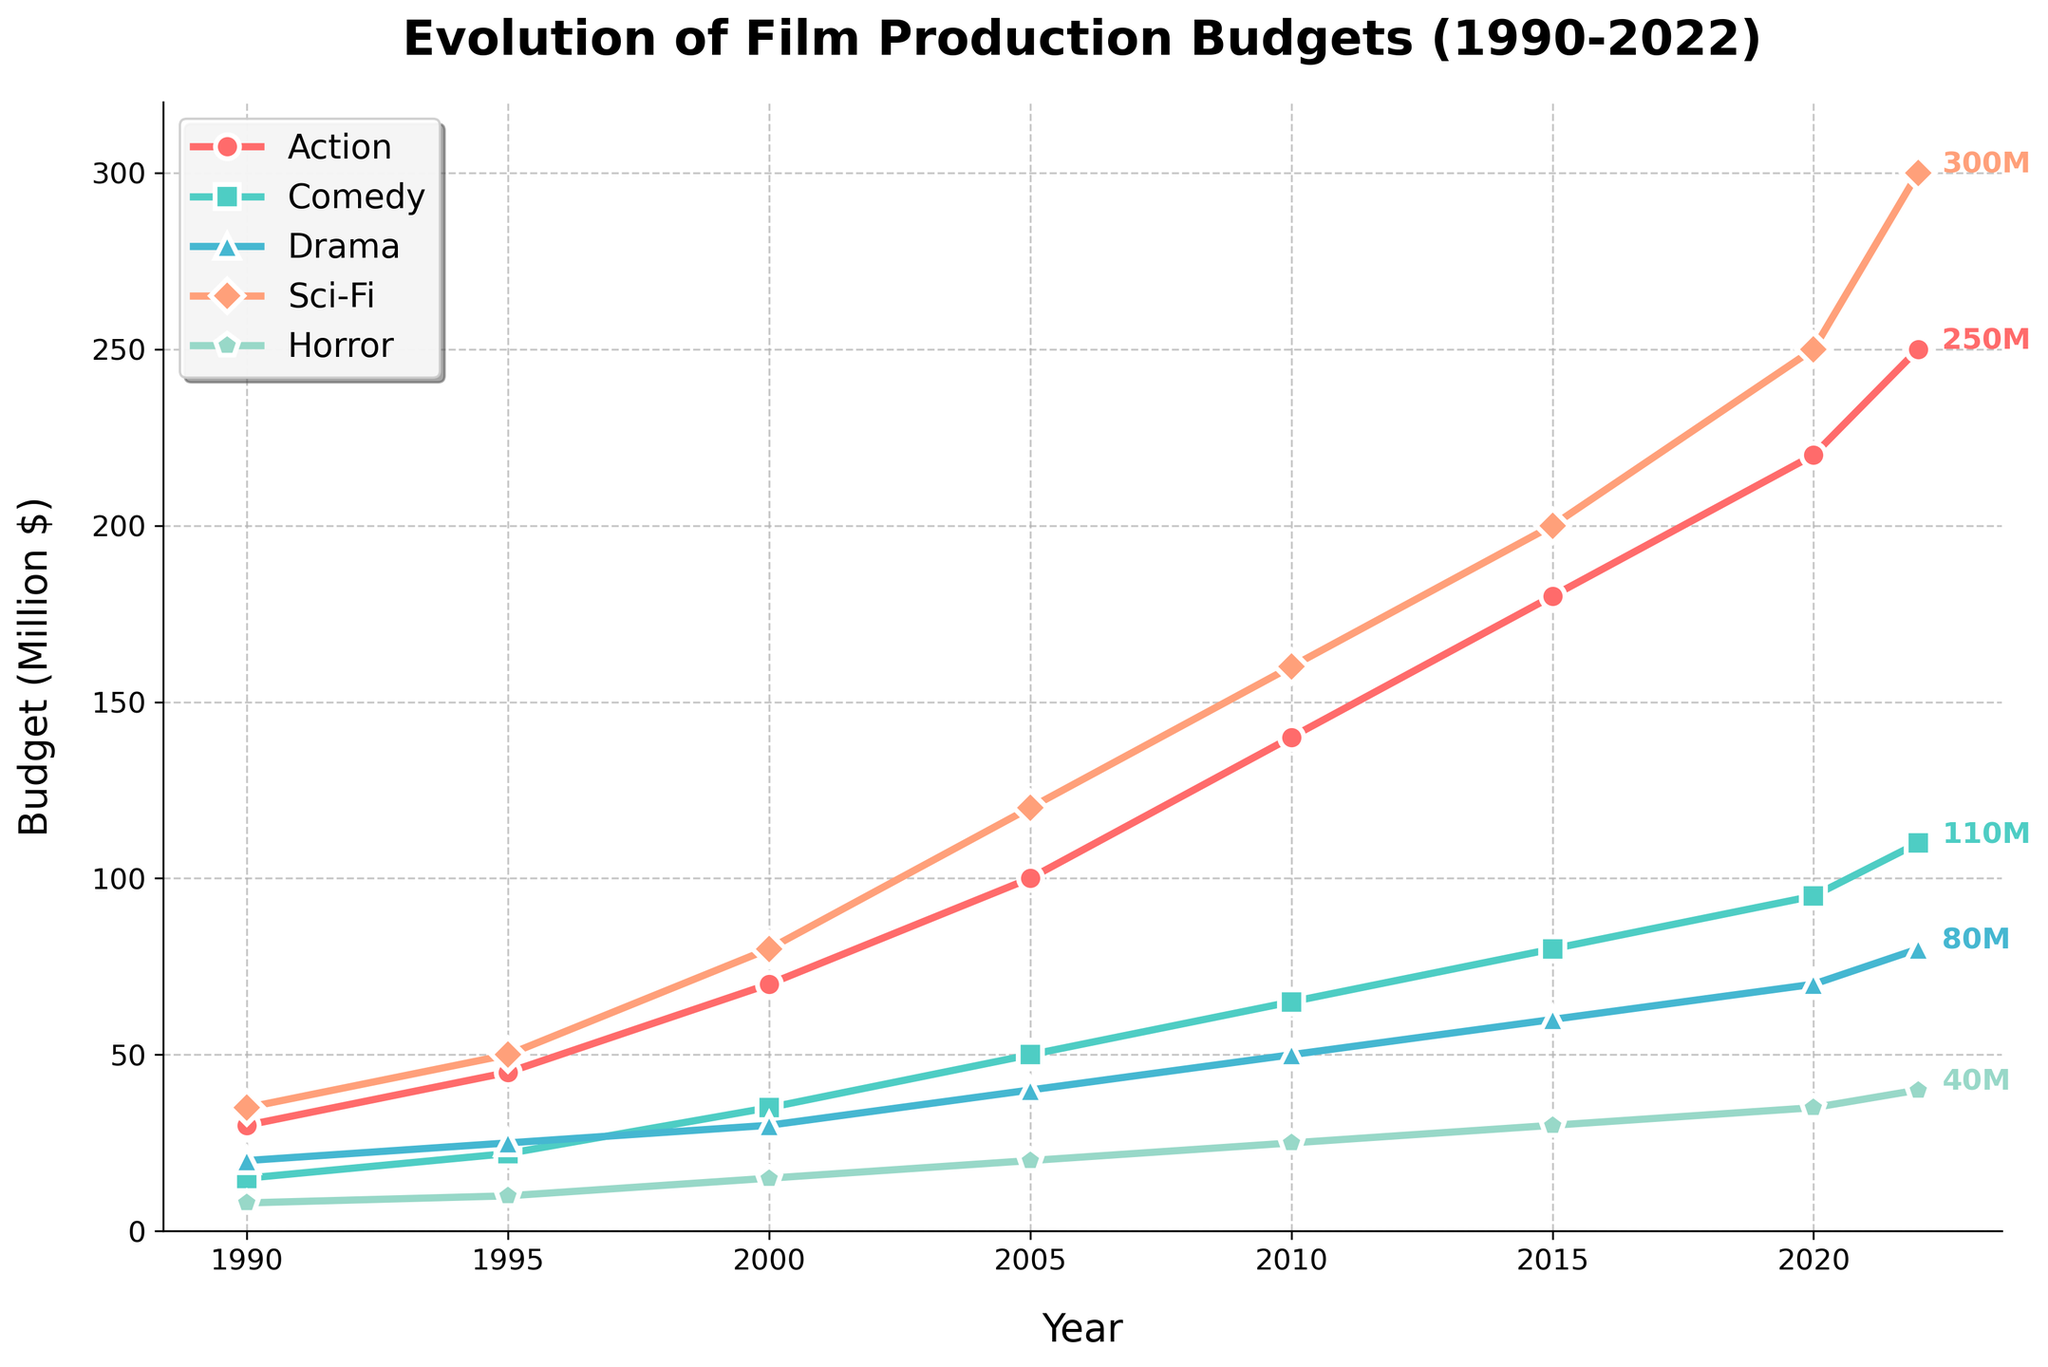How has the budget for Sci-Fi films changed from 1990 to 2022? The line chart shows that Sci-Fi film budgets increased from 1990 ($35M) to 2022 ($300M). To determine the change, we subtract the 1990 value from the 2022 value: $300M - $35M = $265M.
Answer: Increased by $265M Which genre had the highest budget in 2022? Look at the final data points for each genre in 2022. Sci-Fi has the highest budget at $300M compared to others.
Answer: Sci-Fi Compare the trend of budget growth in Action films to Comedy films between 2000 and 2010. From the plot, Action film budgets increased from $70M (2000) to $140M (2010), a difference of $70M. Comedy film budgets increased from $35M (2000) to $65M (2010), a difference of $30M.
Answer: Action grew faster Which genre saw the least amount of budget increase between 2000 and 2022? Calculate the difference for each genre:
- Action: $250M - $70M = $180M
- Comedy: $110M - $35M = $75M
- Drama: $80M - $30M = $50M
- Sci-Fi: $300M - $80M = $220M
- Horror: $40M - $15M = $25M
Horror saw the least increase.
Answer: Horror What is the visual indication that Drama films are less costly compared to other genres in 2022? In 2022, Drama's budget ($80M) is visibly lower with a distinctly shorter marker on the y-axis compared to higher positioned markers for other genres (like $300M for Sci-Fi and $250M for Action).
Answer: Shorter marker for Drama Between which two consecutive years did Action films see the greatest budget increase? Assess the budget increase between each consecutive year for Action films:
- 1990-1995: $15M
- 1995-2000: $25M
- 2000-2005: $30M
- 2005-2010: $40M
- 2010-2015: $40M
- 2015-2020: $40M
- 2020-2022: $30M
The highest increase happened between 2010-2015, 2015-2020, both at $40M.
Answer: 2010-2015 and 2015-2020 What is the total budget for Comedy films from 2010 to 2022? Sum the budgets from 2010, 2015, 2020, and 2022:
$65M + $80M + $95M + $110M = $350M
Answer: $350M How much more was spent on Sci-Fi films compared to Horror films in 2005? Find the budgets for Sci-Fi ($120M) and Horror ($20M) in 2005, and subtract: $120M - $20M = $100M.
Answer: $100M What is the average budget for Drama films over the entire period? Sum Drama budgets from each year (20+25+30+40+50+60+70+80 = 375) and divide by the number of years (8), resulting in an average: $375M / 8 = $46.875M
Answer: $46.875M Which genre has shown a consistent increase in budget every recorded period without any dips? Check each genre's budget progression from one period to the next. Action, Comedy, Drama, Sci-Fi, and Horror all show consistent increases without dips.
Answer: All genres 